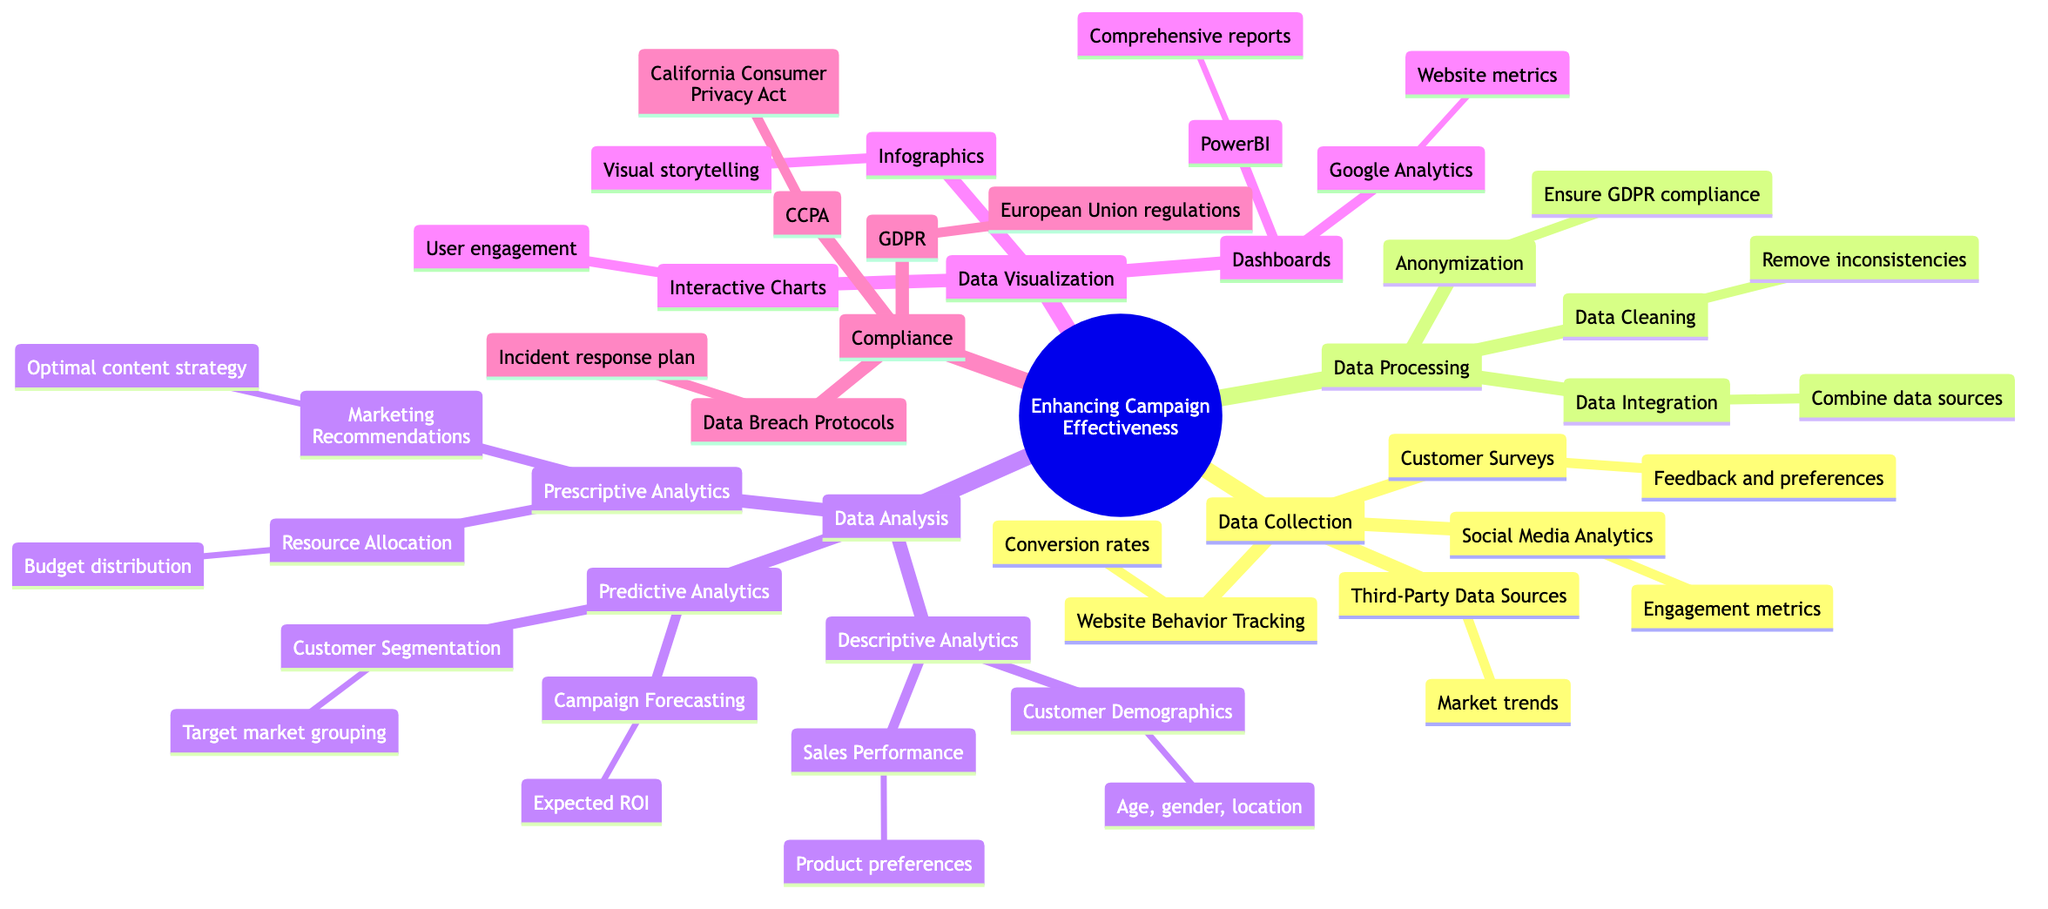What are the four methods of data collection listed? The diagram specifically identifies Customer Surveys, Social Media Analytics, Website Behavior Tracking, and Third-Party Data Sources as the four methods of data collection under that category.
Answer: Customer Surveys, Social Media Analytics, Website Behavior Tracking, Third-Party Data Sources How many types of data analysis are shown in the diagram? The diagram shows three types of data analysis: Descriptive Analytics, Predictive Analytics, and Prescriptive Analytics. By counting these categories, we reach the total number of types which is three.
Answer: Three What does GDPR stand for in the compliance section? GDPR stands for General Data Protection Regulation, which is explicitly stated in the compliance section of the diagram.
Answer: General Data Protection Regulation Which type of analytics focuses on market grouping? The diagram indicates that Customer Segmentation falls under Predictive Analytics and it is primarily concerned with target market grouping.
Answer: Predictive Analytics What is the main purpose of data cleaning in data processing? Data cleaning aims to remove inconsistencies in the data, as stated in the diagram, which helps ensure data accuracy and reliability.
Answer: Remove inconsistencies Which tool is mentioned for creating dashboards? Google Analytics is mentioned in the dashboard creation section of the diagram, which is used to analyze website metrics.
Answer: Google Analytics How many compliance regulations are mentioned? The diagram lists three compliance regulations: GDPR, CCPA, and Data Breach Protocols. By counting these elements directly from the compliance section, we find the total is three.
Answer: Three What is the focus of prescriptive analytics as described? The focus of prescriptive analytics, as laid out in the diagram, includes Marketing Recommendations and Resource Allocation, providing advice for marketing strategies and budget distribution.
Answer: Marketing Recommendations and Resource Allocation What visualization method is used for user engagement? The diagram indicates that Interactive Charts are specifically designated for enhancing user engagement within the Data Visualization section.
Answer: Interactive Charts 